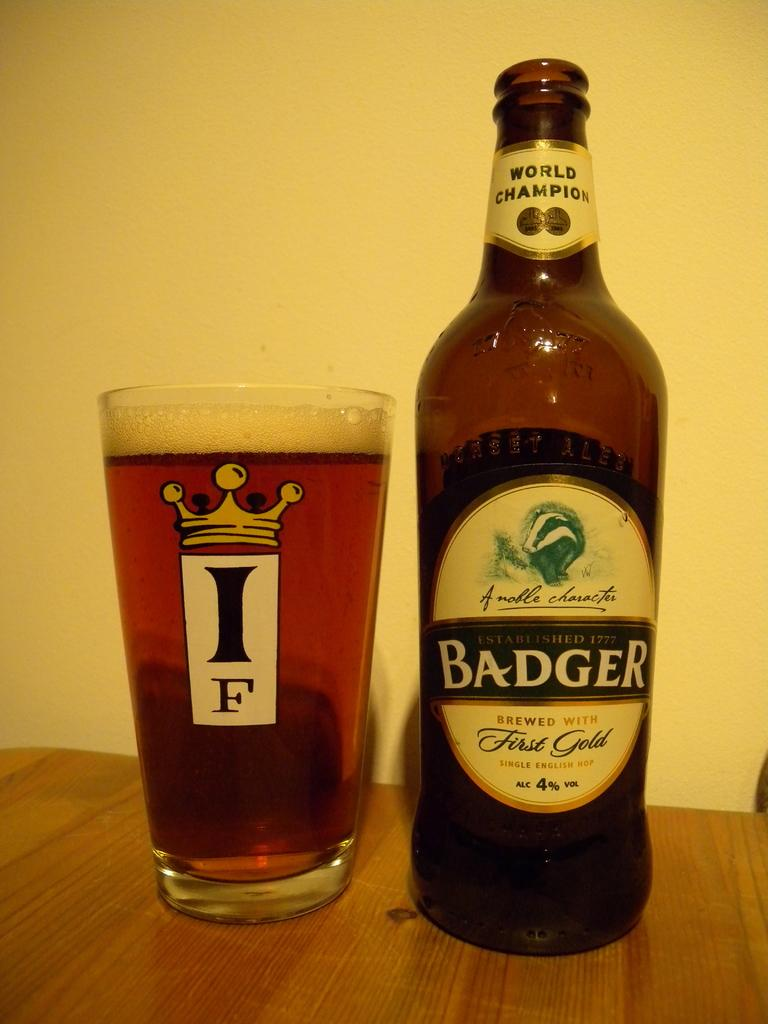<image>
Present a compact description of the photo's key features. A bottle of Badger beer poured into a glass next to it. 